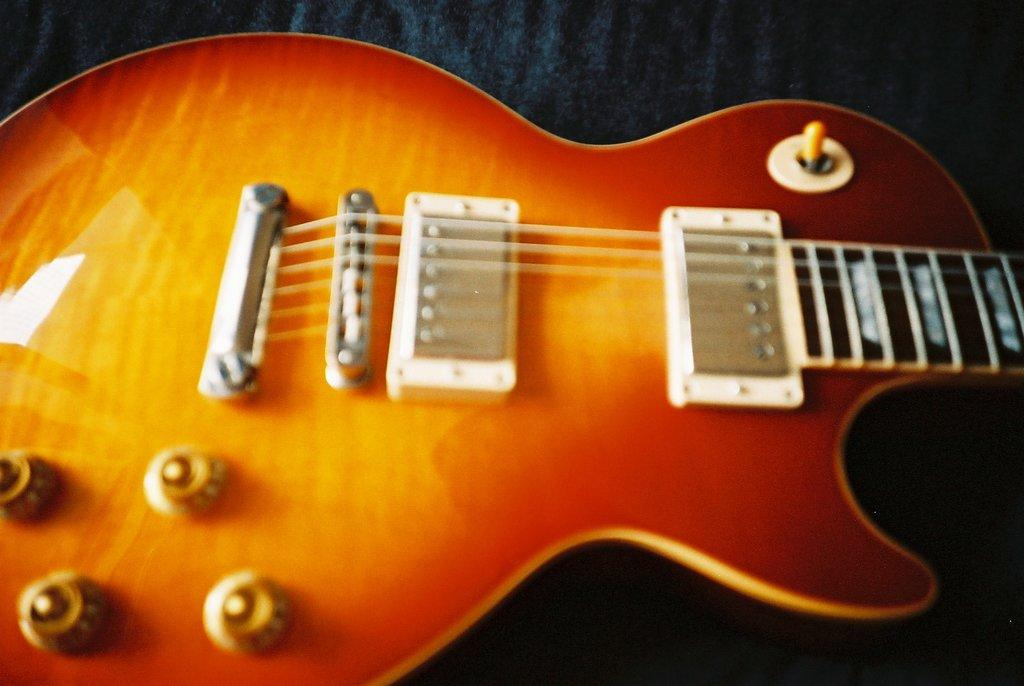What musical instrument is in the image? There is a guitar in the image. What colors are present on the guitar? The guitar has orange and red colors. What is a key feature of the guitar? The guitar has strings. What is the surface beneath the guitar? The guitar is on a black surface. What type of lawyer is present in the image? There are no lawyers present in the image; it features a guitar. What noise can be heard coming from the guitar in the image? The image is still, so no sound can be heard. 